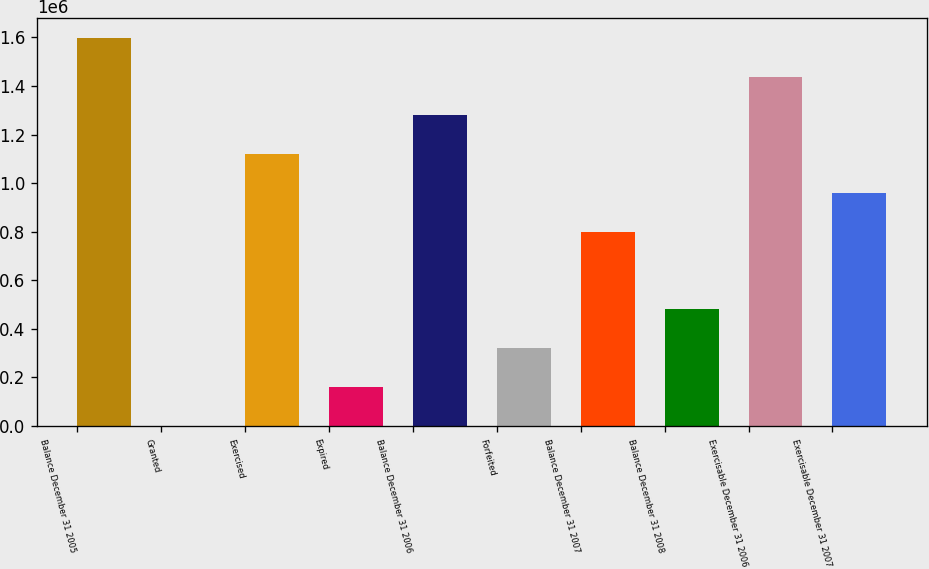<chart> <loc_0><loc_0><loc_500><loc_500><bar_chart><fcel>Balance December 31 2005<fcel>Granted<fcel>Exercised<fcel>Expired<fcel>Balance December 31 2006<fcel>Forfeited<fcel>Balance December 31 2007<fcel>Balance December 31 2008<fcel>Exercisable December 31 2006<fcel>Exercisable December 31 2007<nl><fcel>1.5988e+06<fcel>1800<fcel>1.1197e+06<fcel>161500<fcel>1.2794e+06<fcel>321200<fcel>800300<fcel>480900<fcel>1.4391e+06<fcel>960000<nl></chart> 